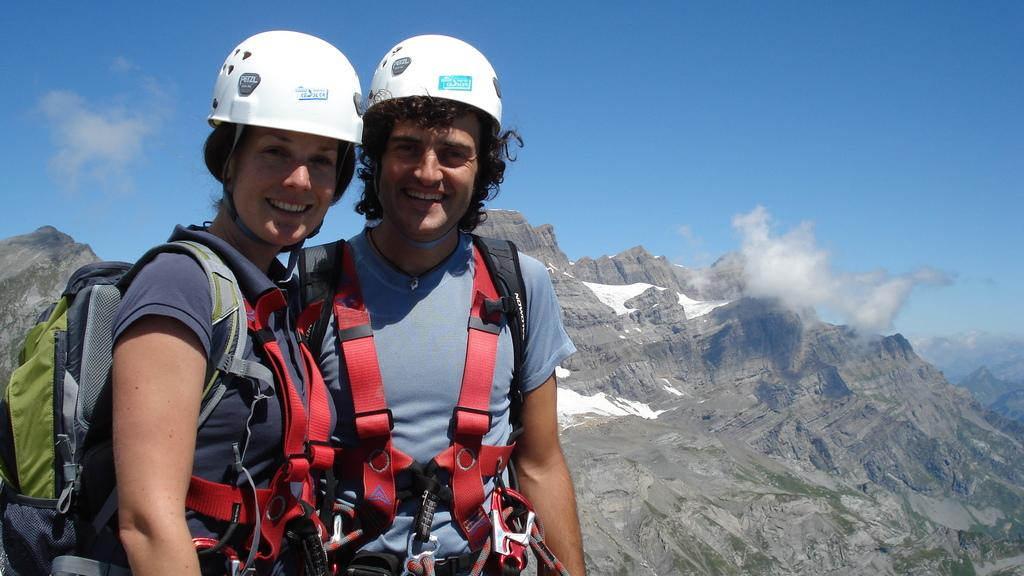What can be seen in the background of the image? There is a sky in the image. What geographical feature is present in the image? There is a hill in the image. How many people are in the image? There are two people standing in the image. What type of whistle can be heard in the image? There is no whistle present or audible in the image. 